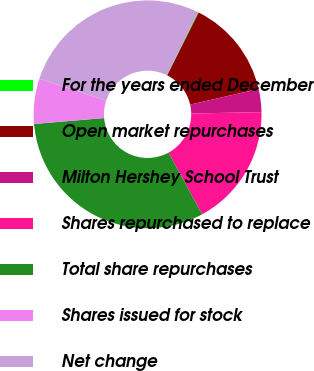Convert chart. <chart><loc_0><loc_0><loc_500><loc_500><pie_chart><fcel>For the years ended December<fcel>Open market repurchases<fcel>Milton Hershey School Trust<fcel>Shares repurchased to replace<fcel>Total share repurchases<fcel>Shares issued for stock<fcel>Net change<nl><fcel>0.12%<fcel>14.02%<fcel>3.27%<fcel>17.36%<fcel>31.6%<fcel>6.42%<fcel>27.22%<nl></chart> 